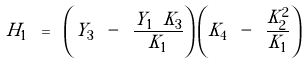<formula> <loc_0><loc_0><loc_500><loc_500>H _ { 1 } \ = \ \left ( Y _ { 3 } \ - \ \frac { Y _ { 1 } \ K _ { 3 } } { K _ { 1 } } \right ) \left ( K _ { 4 } \ - \ \frac { K _ { 2 } ^ { 2 } } { K _ { 1 } } \right )</formula> 